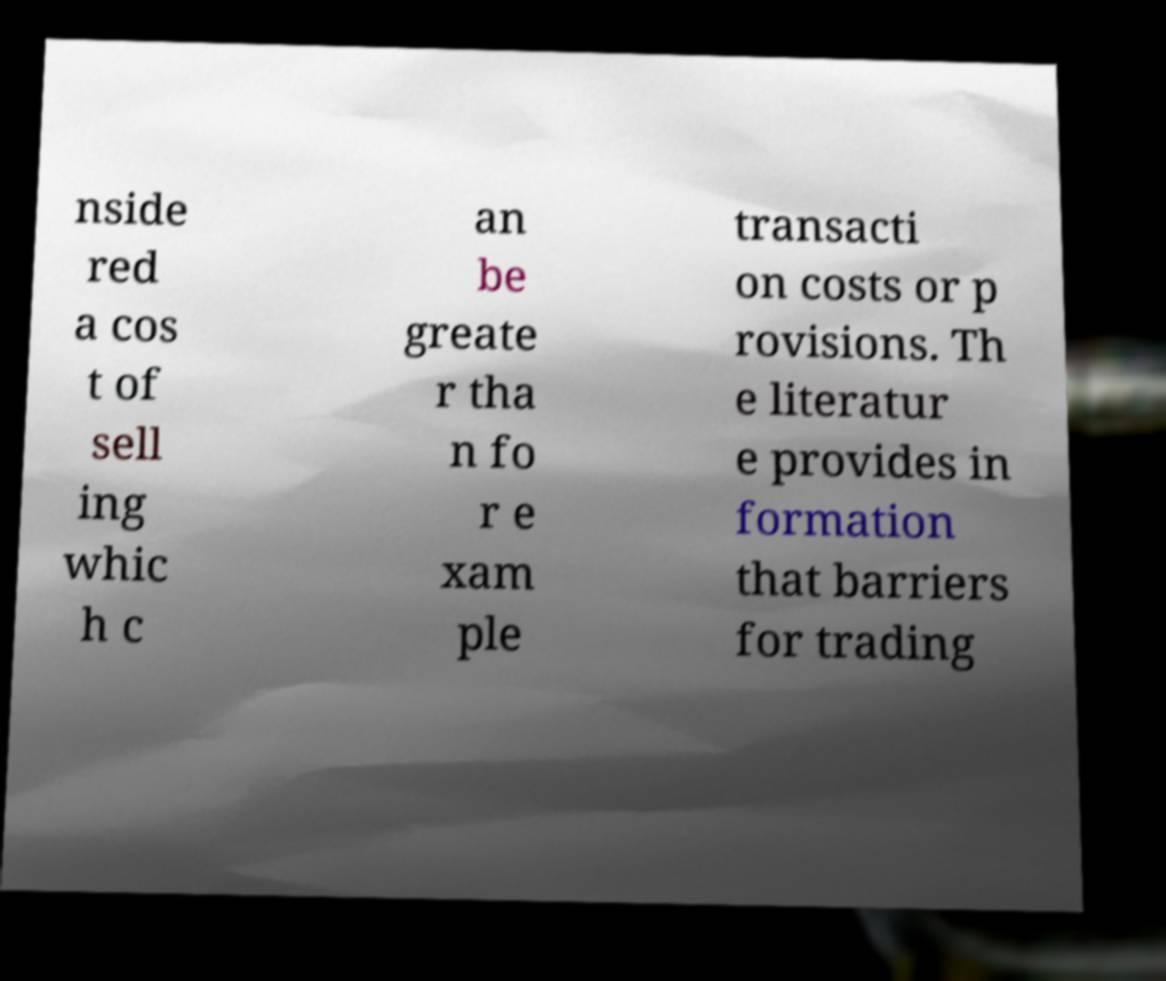For documentation purposes, I need the text within this image transcribed. Could you provide that? nside red a cos t of sell ing whic h c an be greate r tha n fo r e xam ple transacti on costs or p rovisions. Th e literatur e provides in formation that barriers for trading 